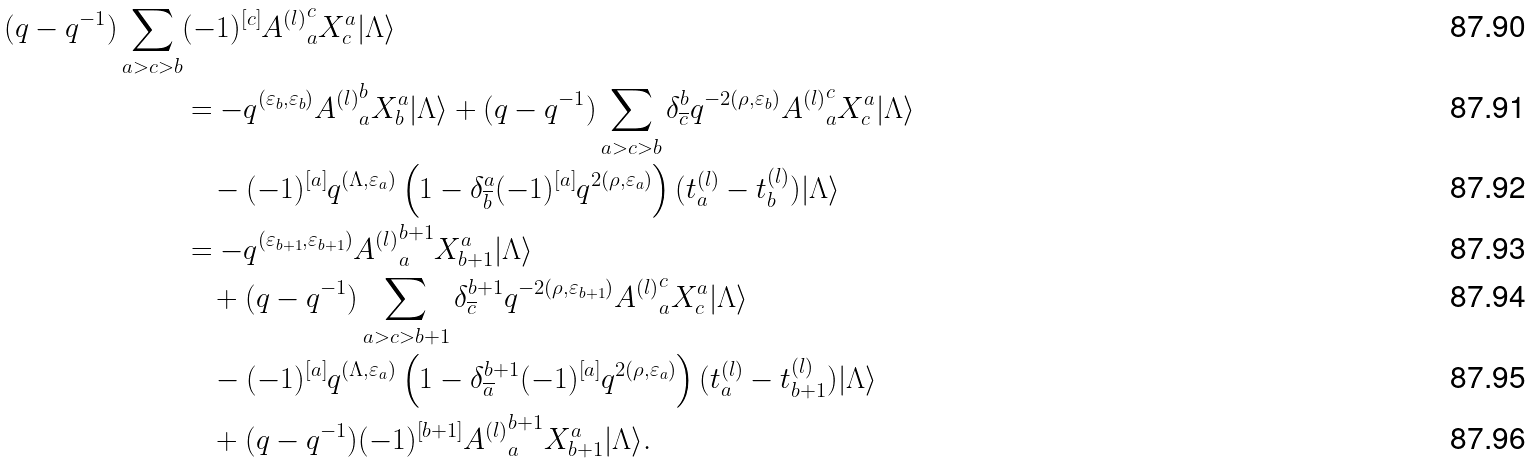Convert formula to latex. <formula><loc_0><loc_0><loc_500><loc_500>( q - q ^ { - 1 } ) \sum _ { a > c > b } & ( - 1 ) ^ { [ c ] } { A ^ { ( l ) } } ^ { c } _ { a } X ^ { a } _ { c } | \Lambda \rangle \\ & = - q ^ { ( \varepsilon _ { b } , \varepsilon _ { b } ) } { A ^ { ( l ) } } ^ { b } _ { a } X ^ { a } _ { b } | \Lambda \rangle + ( q - q ^ { - 1 } ) \sum _ { a > c > b } \delta ^ { b } _ { \overline { c } } q ^ { - 2 ( \rho , \varepsilon _ { b } ) } { A ^ { ( l ) } } ^ { c } _ { a } X ^ { a } _ { c } | \Lambda \rangle \\ & \quad - ( - 1 ) ^ { [ a ] } q ^ { ( \Lambda , \varepsilon _ { a } ) } \left ( 1 - \delta ^ { a } _ { \overline { b } } ( - 1 ) ^ { [ a ] } q ^ { 2 ( \rho , \varepsilon _ { a } ) } \right ) ( t _ { a } ^ { ( l ) } - t _ { b } ^ { ( l ) } ) | \Lambda \rangle \\ & = - q ^ { ( \varepsilon _ { b + 1 } , \varepsilon _ { b + 1 } ) } { A ^ { ( l ) } } ^ { b + 1 } _ { a } X ^ { a } _ { b + 1 } | \Lambda \rangle \\ & \quad + ( q - q ^ { - 1 } ) \sum _ { a > c > b + 1 } \delta ^ { b + 1 } _ { \overline { c } } q ^ { - 2 ( \rho , \varepsilon _ { b + 1 } ) } { A ^ { ( l ) } } ^ { c } _ { a } X ^ { a } _ { c } | \Lambda \rangle \\ & \quad - ( - 1 ) ^ { [ a ] } q ^ { ( \Lambda , \varepsilon _ { a } ) } \left ( 1 - \delta ^ { b + 1 } _ { \overline { a } } ( - 1 ) ^ { [ a ] } q ^ { 2 ( \rho , \varepsilon _ { a } ) } \right ) ( t _ { a } ^ { ( l ) } - t _ { b + 1 } ^ { ( l ) } ) | \Lambda \rangle \\ & \quad + ( q - q ^ { - 1 } ) ( - 1 ) ^ { [ b + 1 ] } { A ^ { ( l ) } } ^ { b + 1 } _ { a } X ^ { a } _ { b + 1 } | \Lambda \rangle .</formula> 